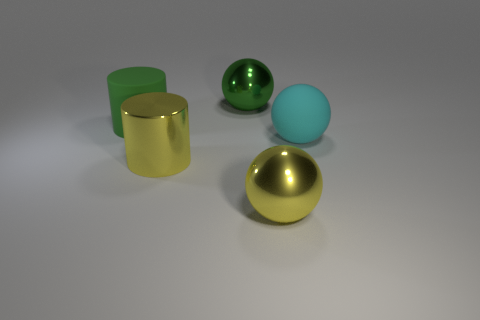Add 5 cyan spheres. How many objects exist? 10 Subtract all spheres. How many objects are left? 2 Add 3 matte cylinders. How many matte cylinders exist? 4 Subtract 0 brown cubes. How many objects are left? 5 Subtract all tiny purple cubes. Subtract all large green balls. How many objects are left? 4 Add 4 yellow cylinders. How many yellow cylinders are left? 5 